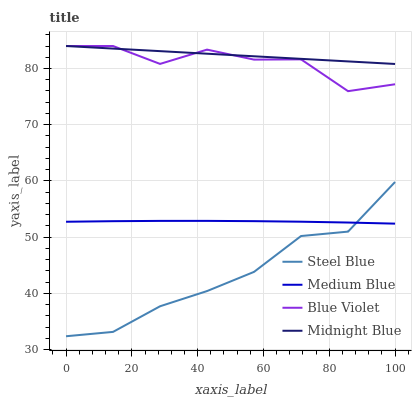Does Steel Blue have the minimum area under the curve?
Answer yes or no. Yes. Does Midnight Blue have the maximum area under the curve?
Answer yes or no. Yes. Does Blue Violet have the minimum area under the curve?
Answer yes or no. No. Does Blue Violet have the maximum area under the curve?
Answer yes or no. No. Is Midnight Blue the smoothest?
Answer yes or no. Yes. Is Blue Violet the roughest?
Answer yes or no. Yes. Is Steel Blue the smoothest?
Answer yes or no. No. Is Steel Blue the roughest?
Answer yes or no. No. Does Steel Blue have the lowest value?
Answer yes or no. Yes. Does Blue Violet have the lowest value?
Answer yes or no. No. Does Midnight Blue have the highest value?
Answer yes or no. Yes. Does Steel Blue have the highest value?
Answer yes or no. No. Is Steel Blue less than Midnight Blue?
Answer yes or no. Yes. Is Midnight Blue greater than Steel Blue?
Answer yes or no. Yes. Does Medium Blue intersect Steel Blue?
Answer yes or no. Yes. Is Medium Blue less than Steel Blue?
Answer yes or no. No. Is Medium Blue greater than Steel Blue?
Answer yes or no. No. Does Steel Blue intersect Midnight Blue?
Answer yes or no. No. 